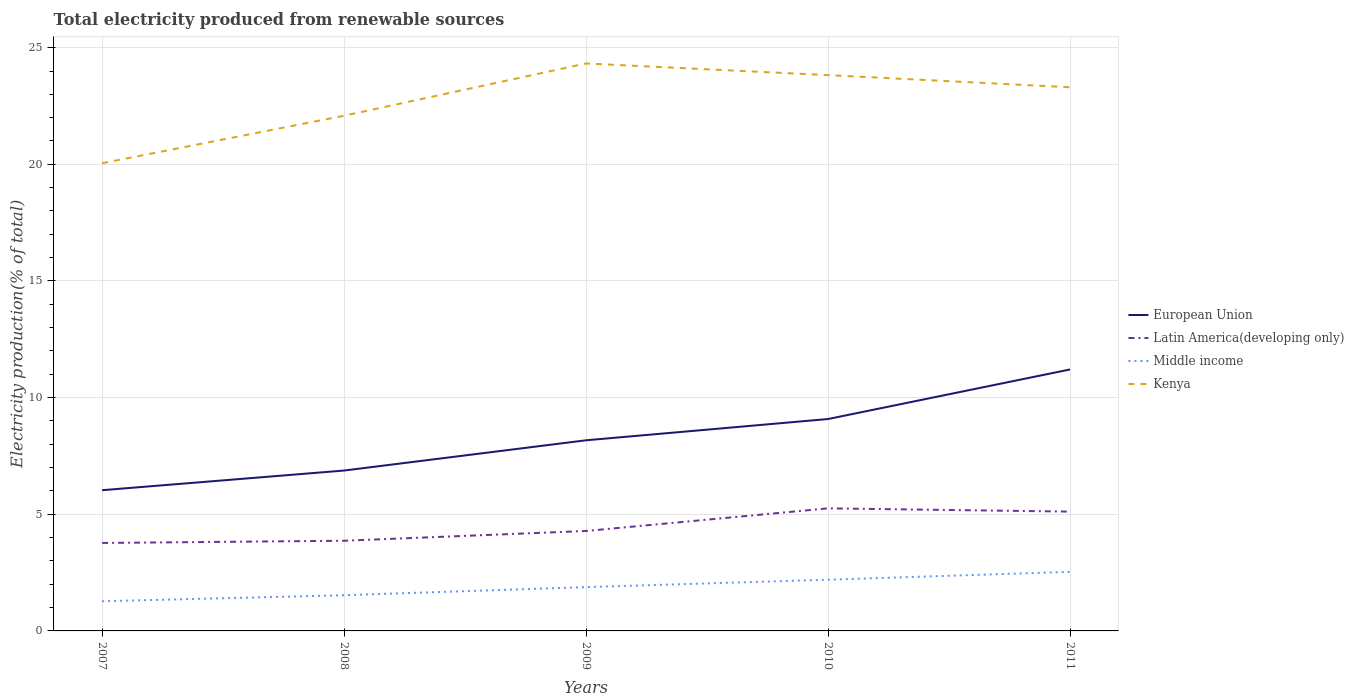How many different coloured lines are there?
Keep it short and to the point. 4. Across all years, what is the maximum total electricity produced in Latin America(developing only)?
Your answer should be compact. 3.77. What is the total total electricity produced in Kenya in the graph?
Make the answer very short. -1.74. What is the difference between the highest and the second highest total electricity produced in Latin America(developing only)?
Your answer should be compact. 1.48. Is the total electricity produced in Kenya strictly greater than the total electricity produced in European Union over the years?
Your answer should be compact. No. Does the graph contain any zero values?
Ensure brevity in your answer.  No. Does the graph contain grids?
Offer a very short reply. Yes. How many legend labels are there?
Keep it short and to the point. 4. What is the title of the graph?
Offer a terse response. Total electricity produced from renewable sources. Does "Europe(all income levels)" appear as one of the legend labels in the graph?
Offer a very short reply. No. What is the label or title of the X-axis?
Ensure brevity in your answer.  Years. What is the Electricity production(% of total) of European Union in 2007?
Offer a terse response. 6.03. What is the Electricity production(% of total) of Latin America(developing only) in 2007?
Offer a very short reply. 3.77. What is the Electricity production(% of total) of Middle income in 2007?
Provide a short and direct response. 1.27. What is the Electricity production(% of total) in Kenya in 2007?
Keep it short and to the point. 20.05. What is the Electricity production(% of total) of European Union in 2008?
Your answer should be compact. 6.87. What is the Electricity production(% of total) in Latin America(developing only) in 2008?
Give a very brief answer. 3.87. What is the Electricity production(% of total) of Middle income in 2008?
Your answer should be compact. 1.53. What is the Electricity production(% of total) in Kenya in 2008?
Your answer should be very brief. 22.08. What is the Electricity production(% of total) in European Union in 2009?
Your answer should be very brief. 8.17. What is the Electricity production(% of total) of Latin America(developing only) in 2009?
Offer a terse response. 4.28. What is the Electricity production(% of total) in Middle income in 2009?
Ensure brevity in your answer.  1.88. What is the Electricity production(% of total) in Kenya in 2009?
Make the answer very short. 24.32. What is the Electricity production(% of total) in European Union in 2010?
Provide a succinct answer. 9.08. What is the Electricity production(% of total) of Latin America(developing only) in 2010?
Keep it short and to the point. 5.25. What is the Electricity production(% of total) of Middle income in 2010?
Keep it short and to the point. 2.2. What is the Electricity production(% of total) of Kenya in 2010?
Your response must be concise. 23.82. What is the Electricity production(% of total) of European Union in 2011?
Keep it short and to the point. 11.21. What is the Electricity production(% of total) in Latin America(developing only) in 2011?
Offer a terse response. 5.11. What is the Electricity production(% of total) in Middle income in 2011?
Your answer should be compact. 2.53. What is the Electricity production(% of total) in Kenya in 2011?
Your answer should be very brief. 23.3. Across all years, what is the maximum Electricity production(% of total) in European Union?
Ensure brevity in your answer.  11.21. Across all years, what is the maximum Electricity production(% of total) in Latin America(developing only)?
Your answer should be compact. 5.25. Across all years, what is the maximum Electricity production(% of total) of Middle income?
Offer a terse response. 2.53. Across all years, what is the maximum Electricity production(% of total) of Kenya?
Make the answer very short. 24.32. Across all years, what is the minimum Electricity production(% of total) of European Union?
Your answer should be compact. 6.03. Across all years, what is the minimum Electricity production(% of total) in Latin America(developing only)?
Give a very brief answer. 3.77. Across all years, what is the minimum Electricity production(% of total) of Middle income?
Make the answer very short. 1.27. Across all years, what is the minimum Electricity production(% of total) of Kenya?
Your answer should be very brief. 20.05. What is the total Electricity production(% of total) of European Union in the graph?
Your answer should be compact. 41.37. What is the total Electricity production(% of total) of Latin America(developing only) in the graph?
Offer a very short reply. 22.29. What is the total Electricity production(% of total) in Middle income in the graph?
Ensure brevity in your answer.  9.41. What is the total Electricity production(% of total) of Kenya in the graph?
Your response must be concise. 113.58. What is the difference between the Electricity production(% of total) of European Union in 2007 and that in 2008?
Your response must be concise. -0.84. What is the difference between the Electricity production(% of total) in Latin America(developing only) in 2007 and that in 2008?
Provide a succinct answer. -0.09. What is the difference between the Electricity production(% of total) of Middle income in 2007 and that in 2008?
Your answer should be compact. -0.26. What is the difference between the Electricity production(% of total) of Kenya in 2007 and that in 2008?
Offer a very short reply. -2.03. What is the difference between the Electricity production(% of total) of European Union in 2007 and that in 2009?
Offer a very short reply. -2.14. What is the difference between the Electricity production(% of total) in Latin America(developing only) in 2007 and that in 2009?
Give a very brief answer. -0.51. What is the difference between the Electricity production(% of total) of Middle income in 2007 and that in 2009?
Ensure brevity in your answer.  -0.61. What is the difference between the Electricity production(% of total) of Kenya in 2007 and that in 2009?
Provide a succinct answer. -4.28. What is the difference between the Electricity production(% of total) in European Union in 2007 and that in 2010?
Keep it short and to the point. -3.05. What is the difference between the Electricity production(% of total) in Latin America(developing only) in 2007 and that in 2010?
Provide a short and direct response. -1.48. What is the difference between the Electricity production(% of total) in Middle income in 2007 and that in 2010?
Provide a succinct answer. -0.92. What is the difference between the Electricity production(% of total) in Kenya in 2007 and that in 2010?
Your response must be concise. -3.78. What is the difference between the Electricity production(% of total) in European Union in 2007 and that in 2011?
Your answer should be very brief. -5.17. What is the difference between the Electricity production(% of total) of Latin America(developing only) in 2007 and that in 2011?
Your response must be concise. -1.34. What is the difference between the Electricity production(% of total) in Middle income in 2007 and that in 2011?
Offer a very short reply. -1.26. What is the difference between the Electricity production(% of total) of Kenya in 2007 and that in 2011?
Ensure brevity in your answer.  -3.25. What is the difference between the Electricity production(% of total) of European Union in 2008 and that in 2009?
Keep it short and to the point. -1.3. What is the difference between the Electricity production(% of total) of Latin America(developing only) in 2008 and that in 2009?
Offer a terse response. -0.42. What is the difference between the Electricity production(% of total) in Middle income in 2008 and that in 2009?
Your answer should be very brief. -0.35. What is the difference between the Electricity production(% of total) of Kenya in 2008 and that in 2009?
Provide a short and direct response. -2.24. What is the difference between the Electricity production(% of total) of European Union in 2008 and that in 2010?
Your answer should be very brief. -2.21. What is the difference between the Electricity production(% of total) in Latin America(developing only) in 2008 and that in 2010?
Give a very brief answer. -1.39. What is the difference between the Electricity production(% of total) in Middle income in 2008 and that in 2010?
Provide a succinct answer. -0.66. What is the difference between the Electricity production(% of total) in Kenya in 2008 and that in 2010?
Your answer should be very brief. -1.74. What is the difference between the Electricity production(% of total) of European Union in 2008 and that in 2011?
Make the answer very short. -4.33. What is the difference between the Electricity production(% of total) in Latin America(developing only) in 2008 and that in 2011?
Offer a very short reply. -1.25. What is the difference between the Electricity production(% of total) in Middle income in 2008 and that in 2011?
Provide a short and direct response. -1. What is the difference between the Electricity production(% of total) of Kenya in 2008 and that in 2011?
Give a very brief answer. -1.22. What is the difference between the Electricity production(% of total) in European Union in 2009 and that in 2010?
Offer a very short reply. -0.91. What is the difference between the Electricity production(% of total) of Latin America(developing only) in 2009 and that in 2010?
Provide a short and direct response. -0.97. What is the difference between the Electricity production(% of total) in Middle income in 2009 and that in 2010?
Give a very brief answer. -0.32. What is the difference between the Electricity production(% of total) in Kenya in 2009 and that in 2010?
Give a very brief answer. 0.5. What is the difference between the Electricity production(% of total) in European Union in 2009 and that in 2011?
Provide a succinct answer. -3.04. What is the difference between the Electricity production(% of total) in Latin America(developing only) in 2009 and that in 2011?
Provide a short and direct response. -0.83. What is the difference between the Electricity production(% of total) of Middle income in 2009 and that in 2011?
Give a very brief answer. -0.65. What is the difference between the Electricity production(% of total) of Kenya in 2009 and that in 2011?
Ensure brevity in your answer.  1.02. What is the difference between the Electricity production(% of total) of European Union in 2010 and that in 2011?
Offer a very short reply. -2.12. What is the difference between the Electricity production(% of total) in Latin America(developing only) in 2010 and that in 2011?
Your answer should be compact. 0.14. What is the difference between the Electricity production(% of total) in Middle income in 2010 and that in 2011?
Your answer should be very brief. -0.34. What is the difference between the Electricity production(% of total) in Kenya in 2010 and that in 2011?
Provide a short and direct response. 0.52. What is the difference between the Electricity production(% of total) in European Union in 2007 and the Electricity production(% of total) in Latin America(developing only) in 2008?
Make the answer very short. 2.17. What is the difference between the Electricity production(% of total) of European Union in 2007 and the Electricity production(% of total) of Middle income in 2008?
Offer a very short reply. 4.5. What is the difference between the Electricity production(% of total) in European Union in 2007 and the Electricity production(% of total) in Kenya in 2008?
Offer a terse response. -16.05. What is the difference between the Electricity production(% of total) of Latin America(developing only) in 2007 and the Electricity production(% of total) of Middle income in 2008?
Give a very brief answer. 2.24. What is the difference between the Electricity production(% of total) in Latin America(developing only) in 2007 and the Electricity production(% of total) in Kenya in 2008?
Ensure brevity in your answer.  -18.31. What is the difference between the Electricity production(% of total) of Middle income in 2007 and the Electricity production(% of total) of Kenya in 2008?
Your answer should be very brief. -20.81. What is the difference between the Electricity production(% of total) of European Union in 2007 and the Electricity production(% of total) of Latin America(developing only) in 2009?
Your answer should be compact. 1.75. What is the difference between the Electricity production(% of total) in European Union in 2007 and the Electricity production(% of total) in Middle income in 2009?
Your answer should be very brief. 4.15. What is the difference between the Electricity production(% of total) of European Union in 2007 and the Electricity production(% of total) of Kenya in 2009?
Your answer should be very brief. -18.29. What is the difference between the Electricity production(% of total) in Latin America(developing only) in 2007 and the Electricity production(% of total) in Middle income in 2009?
Ensure brevity in your answer.  1.89. What is the difference between the Electricity production(% of total) in Latin America(developing only) in 2007 and the Electricity production(% of total) in Kenya in 2009?
Your response must be concise. -20.55. What is the difference between the Electricity production(% of total) of Middle income in 2007 and the Electricity production(% of total) of Kenya in 2009?
Offer a very short reply. -23.05. What is the difference between the Electricity production(% of total) in European Union in 2007 and the Electricity production(% of total) in Latin America(developing only) in 2010?
Offer a terse response. 0.78. What is the difference between the Electricity production(% of total) in European Union in 2007 and the Electricity production(% of total) in Middle income in 2010?
Offer a terse response. 3.84. What is the difference between the Electricity production(% of total) in European Union in 2007 and the Electricity production(% of total) in Kenya in 2010?
Provide a short and direct response. -17.79. What is the difference between the Electricity production(% of total) of Latin America(developing only) in 2007 and the Electricity production(% of total) of Middle income in 2010?
Offer a terse response. 1.57. What is the difference between the Electricity production(% of total) of Latin America(developing only) in 2007 and the Electricity production(% of total) of Kenya in 2010?
Offer a terse response. -20.05. What is the difference between the Electricity production(% of total) of Middle income in 2007 and the Electricity production(% of total) of Kenya in 2010?
Make the answer very short. -22.55. What is the difference between the Electricity production(% of total) of European Union in 2007 and the Electricity production(% of total) of Latin America(developing only) in 2011?
Offer a terse response. 0.92. What is the difference between the Electricity production(% of total) in European Union in 2007 and the Electricity production(% of total) in Middle income in 2011?
Make the answer very short. 3.5. What is the difference between the Electricity production(% of total) of European Union in 2007 and the Electricity production(% of total) of Kenya in 2011?
Make the answer very short. -17.27. What is the difference between the Electricity production(% of total) of Latin America(developing only) in 2007 and the Electricity production(% of total) of Middle income in 2011?
Make the answer very short. 1.24. What is the difference between the Electricity production(% of total) of Latin America(developing only) in 2007 and the Electricity production(% of total) of Kenya in 2011?
Your response must be concise. -19.53. What is the difference between the Electricity production(% of total) of Middle income in 2007 and the Electricity production(% of total) of Kenya in 2011?
Your answer should be compact. -22.03. What is the difference between the Electricity production(% of total) of European Union in 2008 and the Electricity production(% of total) of Latin America(developing only) in 2009?
Ensure brevity in your answer.  2.59. What is the difference between the Electricity production(% of total) in European Union in 2008 and the Electricity production(% of total) in Middle income in 2009?
Make the answer very short. 5. What is the difference between the Electricity production(% of total) in European Union in 2008 and the Electricity production(% of total) in Kenya in 2009?
Keep it short and to the point. -17.45. What is the difference between the Electricity production(% of total) of Latin America(developing only) in 2008 and the Electricity production(% of total) of Middle income in 2009?
Make the answer very short. 1.99. What is the difference between the Electricity production(% of total) in Latin America(developing only) in 2008 and the Electricity production(% of total) in Kenya in 2009?
Give a very brief answer. -20.46. What is the difference between the Electricity production(% of total) of Middle income in 2008 and the Electricity production(% of total) of Kenya in 2009?
Offer a terse response. -22.79. What is the difference between the Electricity production(% of total) of European Union in 2008 and the Electricity production(% of total) of Latin America(developing only) in 2010?
Keep it short and to the point. 1.62. What is the difference between the Electricity production(% of total) of European Union in 2008 and the Electricity production(% of total) of Middle income in 2010?
Provide a succinct answer. 4.68. What is the difference between the Electricity production(% of total) in European Union in 2008 and the Electricity production(% of total) in Kenya in 2010?
Provide a short and direct response. -16.95. What is the difference between the Electricity production(% of total) of Latin America(developing only) in 2008 and the Electricity production(% of total) of Middle income in 2010?
Offer a very short reply. 1.67. What is the difference between the Electricity production(% of total) in Latin America(developing only) in 2008 and the Electricity production(% of total) in Kenya in 2010?
Give a very brief answer. -19.96. What is the difference between the Electricity production(% of total) of Middle income in 2008 and the Electricity production(% of total) of Kenya in 2010?
Your answer should be very brief. -22.29. What is the difference between the Electricity production(% of total) of European Union in 2008 and the Electricity production(% of total) of Latin America(developing only) in 2011?
Offer a very short reply. 1.76. What is the difference between the Electricity production(% of total) in European Union in 2008 and the Electricity production(% of total) in Middle income in 2011?
Offer a terse response. 4.34. What is the difference between the Electricity production(% of total) of European Union in 2008 and the Electricity production(% of total) of Kenya in 2011?
Your answer should be very brief. -16.43. What is the difference between the Electricity production(% of total) of Latin America(developing only) in 2008 and the Electricity production(% of total) of Middle income in 2011?
Keep it short and to the point. 1.33. What is the difference between the Electricity production(% of total) in Latin America(developing only) in 2008 and the Electricity production(% of total) in Kenya in 2011?
Ensure brevity in your answer.  -19.44. What is the difference between the Electricity production(% of total) of Middle income in 2008 and the Electricity production(% of total) of Kenya in 2011?
Offer a very short reply. -21.77. What is the difference between the Electricity production(% of total) in European Union in 2009 and the Electricity production(% of total) in Latin America(developing only) in 2010?
Offer a very short reply. 2.92. What is the difference between the Electricity production(% of total) of European Union in 2009 and the Electricity production(% of total) of Middle income in 2010?
Your answer should be very brief. 5.98. What is the difference between the Electricity production(% of total) of European Union in 2009 and the Electricity production(% of total) of Kenya in 2010?
Ensure brevity in your answer.  -15.65. What is the difference between the Electricity production(% of total) in Latin America(developing only) in 2009 and the Electricity production(% of total) in Middle income in 2010?
Your answer should be very brief. 2.09. What is the difference between the Electricity production(% of total) in Latin America(developing only) in 2009 and the Electricity production(% of total) in Kenya in 2010?
Your response must be concise. -19.54. What is the difference between the Electricity production(% of total) in Middle income in 2009 and the Electricity production(% of total) in Kenya in 2010?
Ensure brevity in your answer.  -21.95. What is the difference between the Electricity production(% of total) in European Union in 2009 and the Electricity production(% of total) in Latin America(developing only) in 2011?
Give a very brief answer. 3.06. What is the difference between the Electricity production(% of total) in European Union in 2009 and the Electricity production(% of total) in Middle income in 2011?
Keep it short and to the point. 5.64. What is the difference between the Electricity production(% of total) in European Union in 2009 and the Electricity production(% of total) in Kenya in 2011?
Provide a succinct answer. -15.13. What is the difference between the Electricity production(% of total) of Latin America(developing only) in 2009 and the Electricity production(% of total) of Middle income in 2011?
Make the answer very short. 1.75. What is the difference between the Electricity production(% of total) of Latin America(developing only) in 2009 and the Electricity production(% of total) of Kenya in 2011?
Your response must be concise. -19.02. What is the difference between the Electricity production(% of total) in Middle income in 2009 and the Electricity production(% of total) in Kenya in 2011?
Keep it short and to the point. -21.42. What is the difference between the Electricity production(% of total) in European Union in 2010 and the Electricity production(% of total) in Latin America(developing only) in 2011?
Keep it short and to the point. 3.97. What is the difference between the Electricity production(% of total) in European Union in 2010 and the Electricity production(% of total) in Middle income in 2011?
Ensure brevity in your answer.  6.55. What is the difference between the Electricity production(% of total) of European Union in 2010 and the Electricity production(% of total) of Kenya in 2011?
Offer a terse response. -14.22. What is the difference between the Electricity production(% of total) in Latin America(developing only) in 2010 and the Electricity production(% of total) in Middle income in 2011?
Offer a very short reply. 2.72. What is the difference between the Electricity production(% of total) in Latin America(developing only) in 2010 and the Electricity production(% of total) in Kenya in 2011?
Your response must be concise. -18.05. What is the difference between the Electricity production(% of total) of Middle income in 2010 and the Electricity production(% of total) of Kenya in 2011?
Give a very brief answer. -21.11. What is the average Electricity production(% of total) of European Union per year?
Keep it short and to the point. 8.27. What is the average Electricity production(% of total) of Latin America(developing only) per year?
Offer a terse response. 4.46. What is the average Electricity production(% of total) of Middle income per year?
Your answer should be very brief. 1.88. What is the average Electricity production(% of total) in Kenya per year?
Provide a short and direct response. 22.72. In the year 2007, what is the difference between the Electricity production(% of total) in European Union and Electricity production(% of total) in Latin America(developing only)?
Make the answer very short. 2.26. In the year 2007, what is the difference between the Electricity production(% of total) in European Union and Electricity production(% of total) in Middle income?
Your response must be concise. 4.76. In the year 2007, what is the difference between the Electricity production(% of total) of European Union and Electricity production(% of total) of Kenya?
Ensure brevity in your answer.  -14.02. In the year 2007, what is the difference between the Electricity production(% of total) of Latin America(developing only) and Electricity production(% of total) of Middle income?
Provide a short and direct response. 2.5. In the year 2007, what is the difference between the Electricity production(% of total) of Latin America(developing only) and Electricity production(% of total) of Kenya?
Make the answer very short. -16.28. In the year 2007, what is the difference between the Electricity production(% of total) in Middle income and Electricity production(% of total) in Kenya?
Offer a very short reply. -18.78. In the year 2008, what is the difference between the Electricity production(% of total) of European Union and Electricity production(% of total) of Latin America(developing only)?
Your answer should be very brief. 3.01. In the year 2008, what is the difference between the Electricity production(% of total) of European Union and Electricity production(% of total) of Middle income?
Offer a terse response. 5.34. In the year 2008, what is the difference between the Electricity production(% of total) of European Union and Electricity production(% of total) of Kenya?
Your response must be concise. -15.21. In the year 2008, what is the difference between the Electricity production(% of total) in Latin America(developing only) and Electricity production(% of total) in Middle income?
Ensure brevity in your answer.  2.33. In the year 2008, what is the difference between the Electricity production(% of total) of Latin America(developing only) and Electricity production(% of total) of Kenya?
Offer a very short reply. -18.22. In the year 2008, what is the difference between the Electricity production(% of total) in Middle income and Electricity production(% of total) in Kenya?
Offer a terse response. -20.55. In the year 2009, what is the difference between the Electricity production(% of total) of European Union and Electricity production(% of total) of Latin America(developing only)?
Offer a terse response. 3.89. In the year 2009, what is the difference between the Electricity production(% of total) of European Union and Electricity production(% of total) of Middle income?
Your answer should be compact. 6.29. In the year 2009, what is the difference between the Electricity production(% of total) of European Union and Electricity production(% of total) of Kenya?
Offer a terse response. -16.15. In the year 2009, what is the difference between the Electricity production(% of total) of Latin America(developing only) and Electricity production(% of total) of Middle income?
Make the answer very short. 2.41. In the year 2009, what is the difference between the Electricity production(% of total) in Latin America(developing only) and Electricity production(% of total) in Kenya?
Give a very brief answer. -20.04. In the year 2009, what is the difference between the Electricity production(% of total) of Middle income and Electricity production(% of total) of Kenya?
Provide a succinct answer. -22.45. In the year 2010, what is the difference between the Electricity production(% of total) of European Union and Electricity production(% of total) of Latin America(developing only)?
Offer a very short reply. 3.83. In the year 2010, what is the difference between the Electricity production(% of total) of European Union and Electricity production(% of total) of Middle income?
Provide a short and direct response. 6.89. In the year 2010, what is the difference between the Electricity production(% of total) of European Union and Electricity production(% of total) of Kenya?
Your response must be concise. -14.74. In the year 2010, what is the difference between the Electricity production(% of total) in Latin America(developing only) and Electricity production(% of total) in Middle income?
Ensure brevity in your answer.  3.06. In the year 2010, what is the difference between the Electricity production(% of total) in Latin America(developing only) and Electricity production(% of total) in Kenya?
Give a very brief answer. -18.57. In the year 2010, what is the difference between the Electricity production(% of total) of Middle income and Electricity production(% of total) of Kenya?
Make the answer very short. -21.63. In the year 2011, what is the difference between the Electricity production(% of total) in European Union and Electricity production(% of total) in Latin America(developing only)?
Your answer should be compact. 6.09. In the year 2011, what is the difference between the Electricity production(% of total) of European Union and Electricity production(% of total) of Middle income?
Your response must be concise. 8.67. In the year 2011, what is the difference between the Electricity production(% of total) in European Union and Electricity production(% of total) in Kenya?
Provide a short and direct response. -12.1. In the year 2011, what is the difference between the Electricity production(% of total) in Latin America(developing only) and Electricity production(% of total) in Middle income?
Offer a very short reply. 2.58. In the year 2011, what is the difference between the Electricity production(% of total) in Latin America(developing only) and Electricity production(% of total) in Kenya?
Ensure brevity in your answer.  -18.19. In the year 2011, what is the difference between the Electricity production(% of total) of Middle income and Electricity production(% of total) of Kenya?
Your response must be concise. -20.77. What is the ratio of the Electricity production(% of total) of European Union in 2007 to that in 2008?
Your response must be concise. 0.88. What is the ratio of the Electricity production(% of total) in Latin America(developing only) in 2007 to that in 2008?
Provide a succinct answer. 0.98. What is the ratio of the Electricity production(% of total) in Middle income in 2007 to that in 2008?
Provide a succinct answer. 0.83. What is the ratio of the Electricity production(% of total) in Kenya in 2007 to that in 2008?
Your response must be concise. 0.91. What is the ratio of the Electricity production(% of total) in European Union in 2007 to that in 2009?
Your answer should be very brief. 0.74. What is the ratio of the Electricity production(% of total) in Latin America(developing only) in 2007 to that in 2009?
Your answer should be compact. 0.88. What is the ratio of the Electricity production(% of total) of Middle income in 2007 to that in 2009?
Your answer should be very brief. 0.68. What is the ratio of the Electricity production(% of total) in Kenya in 2007 to that in 2009?
Your answer should be very brief. 0.82. What is the ratio of the Electricity production(% of total) of European Union in 2007 to that in 2010?
Your response must be concise. 0.66. What is the ratio of the Electricity production(% of total) in Latin America(developing only) in 2007 to that in 2010?
Give a very brief answer. 0.72. What is the ratio of the Electricity production(% of total) in Middle income in 2007 to that in 2010?
Provide a succinct answer. 0.58. What is the ratio of the Electricity production(% of total) of Kenya in 2007 to that in 2010?
Offer a terse response. 0.84. What is the ratio of the Electricity production(% of total) of European Union in 2007 to that in 2011?
Keep it short and to the point. 0.54. What is the ratio of the Electricity production(% of total) of Latin America(developing only) in 2007 to that in 2011?
Offer a very short reply. 0.74. What is the ratio of the Electricity production(% of total) of Middle income in 2007 to that in 2011?
Offer a very short reply. 0.5. What is the ratio of the Electricity production(% of total) of Kenya in 2007 to that in 2011?
Your answer should be very brief. 0.86. What is the ratio of the Electricity production(% of total) of European Union in 2008 to that in 2009?
Your answer should be compact. 0.84. What is the ratio of the Electricity production(% of total) in Latin America(developing only) in 2008 to that in 2009?
Ensure brevity in your answer.  0.9. What is the ratio of the Electricity production(% of total) of Middle income in 2008 to that in 2009?
Provide a short and direct response. 0.82. What is the ratio of the Electricity production(% of total) of Kenya in 2008 to that in 2009?
Provide a succinct answer. 0.91. What is the ratio of the Electricity production(% of total) of European Union in 2008 to that in 2010?
Keep it short and to the point. 0.76. What is the ratio of the Electricity production(% of total) in Latin America(developing only) in 2008 to that in 2010?
Give a very brief answer. 0.74. What is the ratio of the Electricity production(% of total) of Middle income in 2008 to that in 2010?
Ensure brevity in your answer.  0.7. What is the ratio of the Electricity production(% of total) in Kenya in 2008 to that in 2010?
Your answer should be very brief. 0.93. What is the ratio of the Electricity production(% of total) in European Union in 2008 to that in 2011?
Your answer should be very brief. 0.61. What is the ratio of the Electricity production(% of total) in Latin America(developing only) in 2008 to that in 2011?
Provide a short and direct response. 0.76. What is the ratio of the Electricity production(% of total) of Middle income in 2008 to that in 2011?
Provide a short and direct response. 0.6. What is the ratio of the Electricity production(% of total) in Kenya in 2008 to that in 2011?
Ensure brevity in your answer.  0.95. What is the ratio of the Electricity production(% of total) of European Union in 2009 to that in 2010?
Your answer should be compact. 0.9. What is the ratio of the Electricity production(% of total) in Latin America(developing only) in 2009 to that in 2010?
Give a very brief answer. 0.82. What is the ratio of the Electricity production(% of total) of Middle income in 2009 to that in 2010?
Ensure brevity in your answer.  0.86. What is the ratio of the Electricity production(% of total) of European Union in 2009 to that in 2011?
Make the answer very short. 0.73. What is the ratio of the Electricity production(% of total) of Latin America(developing only) in 2009 to that in 2011?
Keep it short and to the point. 0.84. What is the ratio of the Electricity production(% of total) of Middle income in 2009 to that in 2011?
Give a very brief answer. 0.74. What is the ratio of the Electricity production(% of total) of Kenya in 2009 to that in 2011?
Keep it short and to the point. 1.04. What is the ratio of the Electricity production(% of total) of European Union in 2010 to that in 2011?
Your response must be concise. 0.81. What is the ratio of the Electricity production(% of total) in Latin America(developing only) in 2010 to that in 2011?
Your answer should be compact. 1.03. What is the ratio of the Electricity production(% of total) of Middle income in 2010 to that in 2011?
Keep it short and to the point. 0.87. What is the ratio of the Electricity production(% of total) of Kenya in 2010 to that in 2011?
Your answer should be very brief. 1.02. What is the difference between the highest and the second highest Electricity production(% of total) of European Union?
Ensure brevity in your answer.  2.12. What is the difference between the highest and the second highest Electricity production(% of total) in Latin America(developing only)?
Keep it short and to the point. 0.14. What is the difference between the highest and the second highest Electricity production(% of total) in Middle income?
Offer a terse response. 0.34. What is the difference between the highest and the second highest Electricity production(% of total) of Kenya?
Give a very brief answer. 0.5. What is the difference between the highest and the lowest Electricity production(% of total) of European Union?
Give a very brief answer. 5.17. What is the difference between the highest and the lowest Electricity production(% of total) in Latin America(developing only)?
Give a very brief answer. 1.48. What is the difference between the highest and the lowest Electricity production(% of total) of Middle income?
Provide a succinct answer. 1.26. What is the difference between the highest and the lowest Electricity production(% of total) of Kenya?
Offer a very short reply. 4.28. 